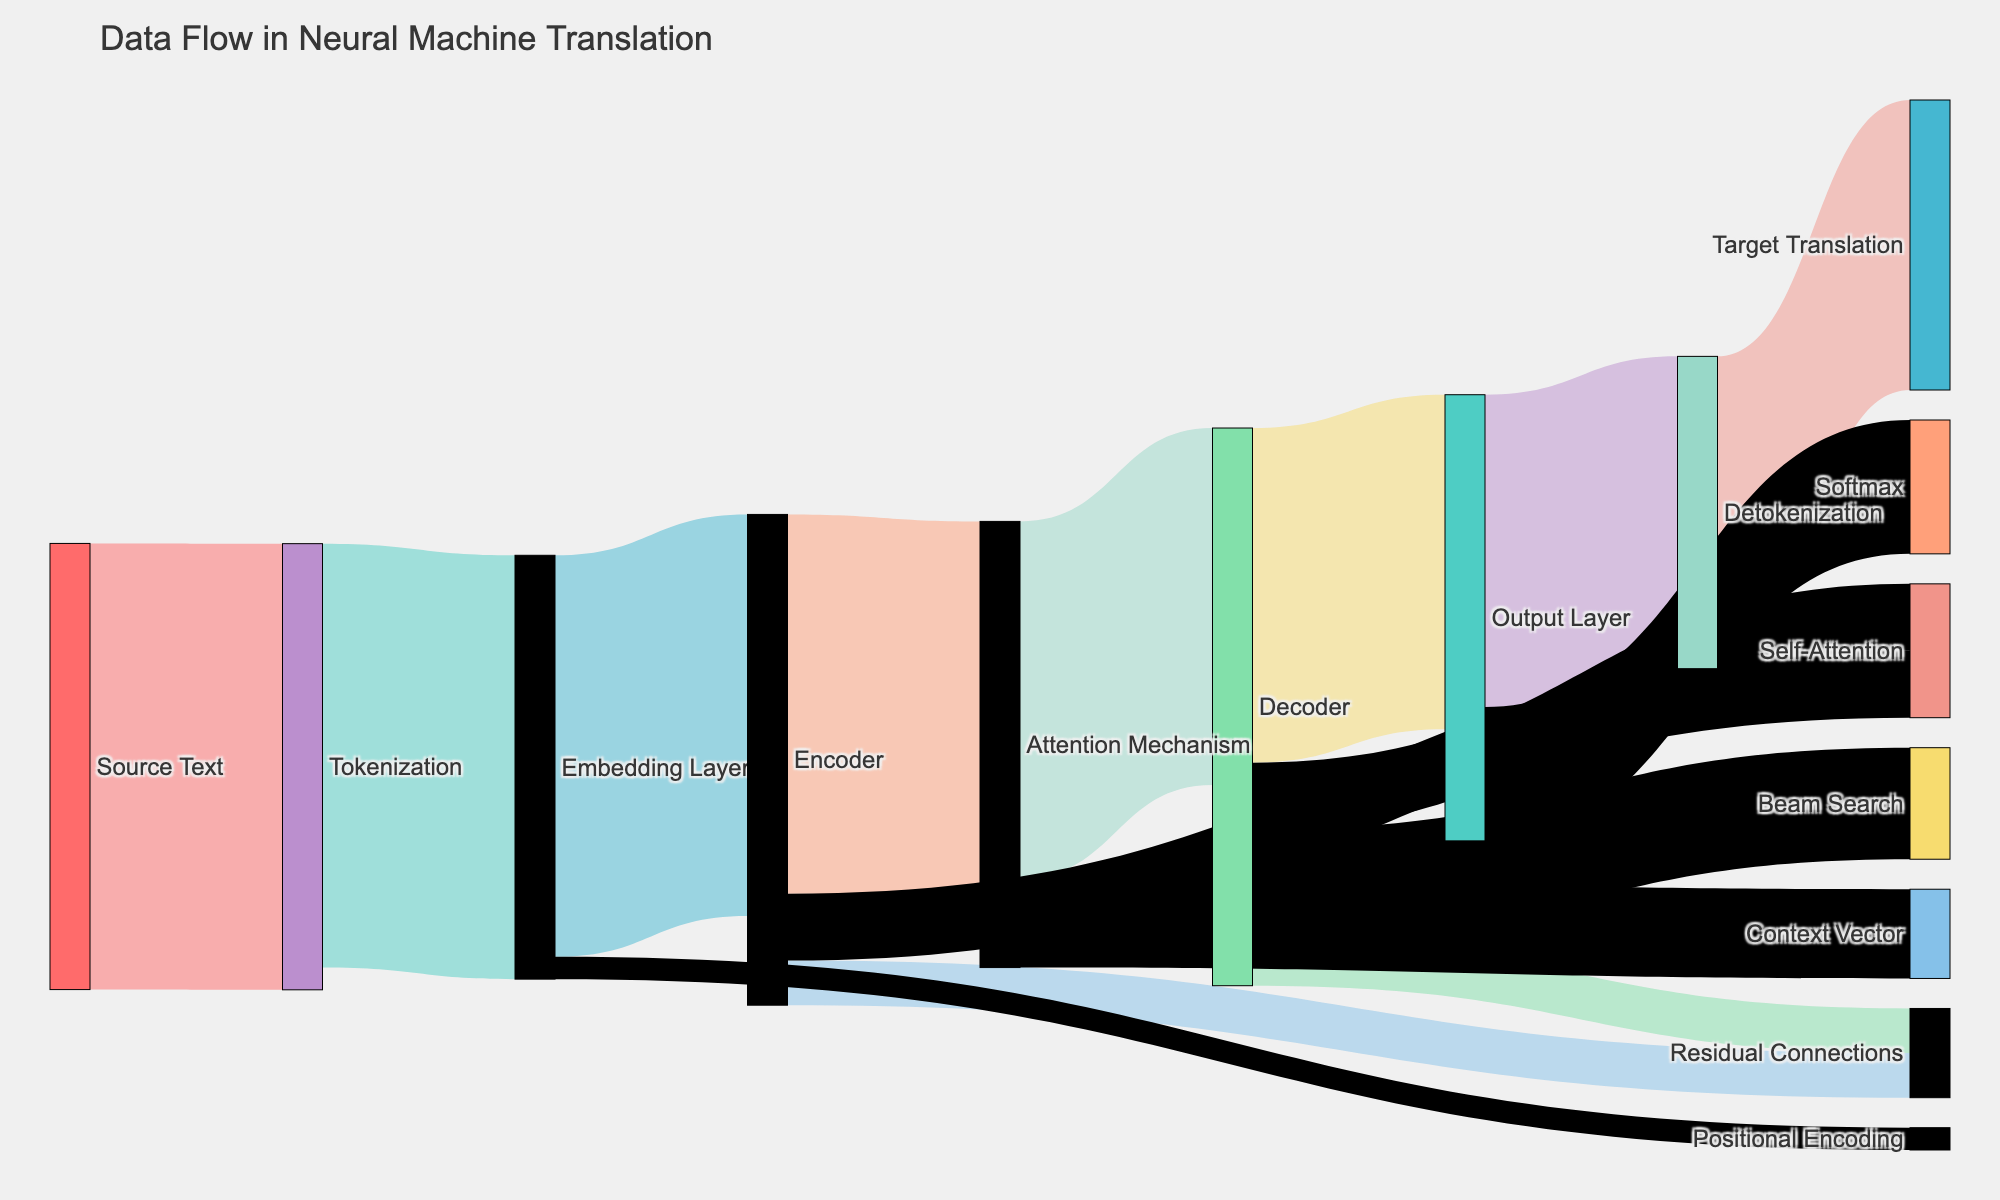What is the title of the Sankey Diagram? The title of the Sankey Diagram is typically displayed at the top of the figure. In this case, it's specified in the code.
Answer: Data Flow in Neural Machine Translation How many unique nodes are there in the diagram? The unique nodes are derived from the combined set of source and target elements. Listing all nodes and counting them gives the total number.
Answer: 14 Which process has the highest value flowing into it? The process with the highest incoming value can be determined by identifying which target has the largest 'value' connected to it. Here, the Tokenization process receives the highest value from Source Text.
Answer: Tokenization What is the combined value flowing from "Self-Attention" nodes? To find the combined value, add the values of flows from both Encoder's Self-Attention and Decoder's Self-Attention.
Answer: 30 (15 from Encoder's Self-Attention + 15 from Decoder's Self-Attention) What is the sum of values flowing into the Decoder? Sum the values of all connections leading into the Decoder node (from Attention Mechanism and Self-Attention).
Answer: 95 (80 + 15) Is the value flowing from Positional Encoding to Encoder greater than or less than that from Residual Connections to Encoder? Compare the flow values from Positional Encoding (5) and Residual Connections (10) to Encoder.
Answer: Less than Describe the sequence of steps in the data flow from "Attention Mechanism" to "Target Translation." By tracing the connections from Attention Mechanism, determine the sequential nodes it flows into until reaching Target Translation.
Answer: Attention Mechanism -> Decoder -> Output Layer -> Detokenization -> Target Translation Which nodes have connections directly coming from the Embedding Layer? Identify all nodes that receive a direct flow from Embedding Layer by checking the target nodes where the source is Embedding Layer.
Answer: Encoder, Positional Encoding Between "Beam Search" and "Softmax," which has a higher value flowing into it? Compare the values flowing into Beam Search (25) and Softmax (30).
Answer: Softmax How many processes in total contribute to the 'Target Translation' node? Count all distinct source nodes from which the flow eventually reaches Target Translation.
Answer: 7 